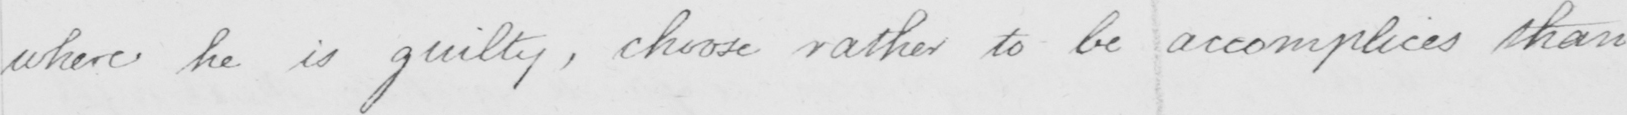What text is written in this handwritten line? where he is guilty , choose rather to be accomplices than 